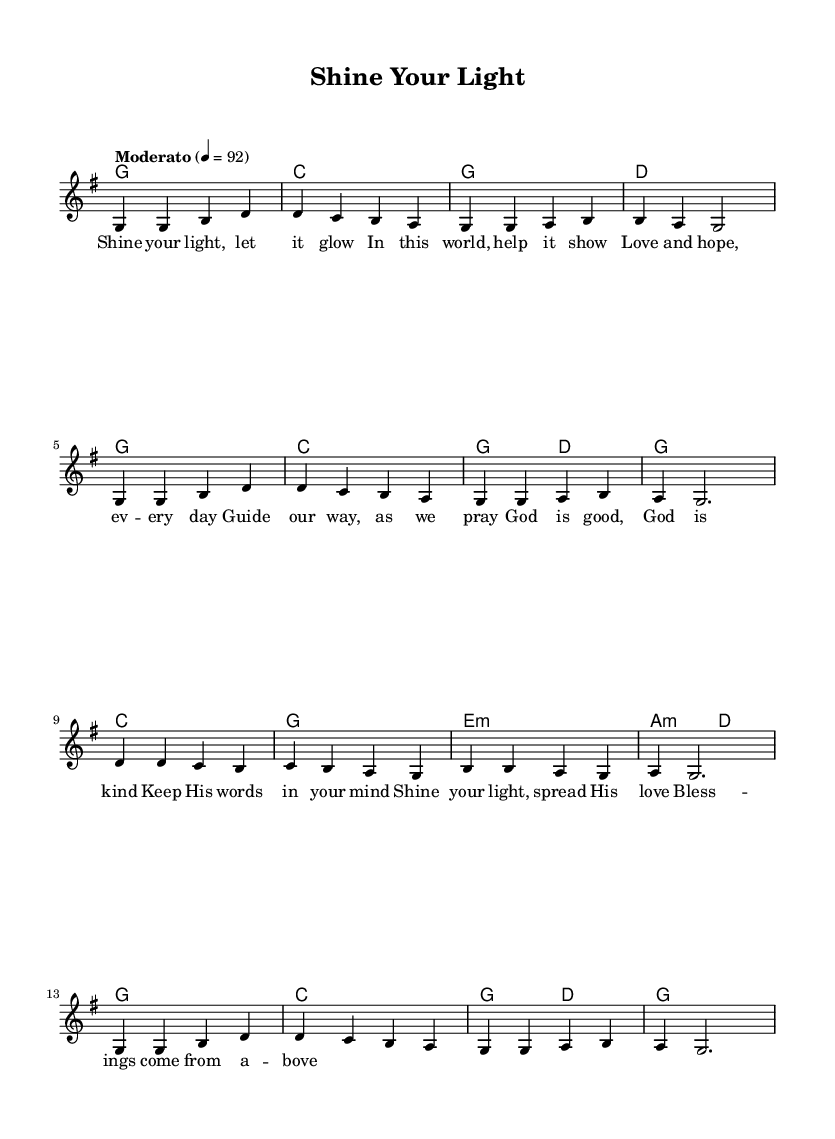What is the key signature of this music? The key signature shows a G major with one sharp (F#). The key signature is usually found at the beginning of the staff before the time signature.
Answer: G major What is the time signature of this music? The time signature is indicated at the beginning of the piece. Here, it shows that there are 4 beats in a measure, represented as 4/4.
Answer: 4/4 What is the tempo indicated in this music? The tempo marking is found at the beginning, which is set at "Moderato" with a metronome marking of 92, indicating a moderate speed.
Answer: 92 How many measures are in this piece? By counting the individual groups of notes between the vertical bar lines, we see there are 12 measures total in the melody section.
Answer: 12 What is the primary theme of the lyrics? The lyrics speak about shining one's light, love, and guidance, common themes in uplifting Christian music. By reading the words, we can see it emphasizes positivity and support through faith.
Answer: Shine your light Which chord appears most frequently in the harmonies? By examining the chord progression, it shows that the G chord appears multiple times throughout the score. It is present in many measures, indicating it's the most used chord here.
Answer: G 